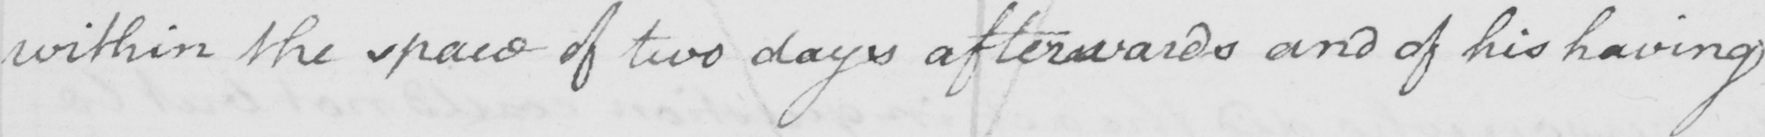Please provide the text content of this handwritten line. within the space of two days afterwards and of his having 